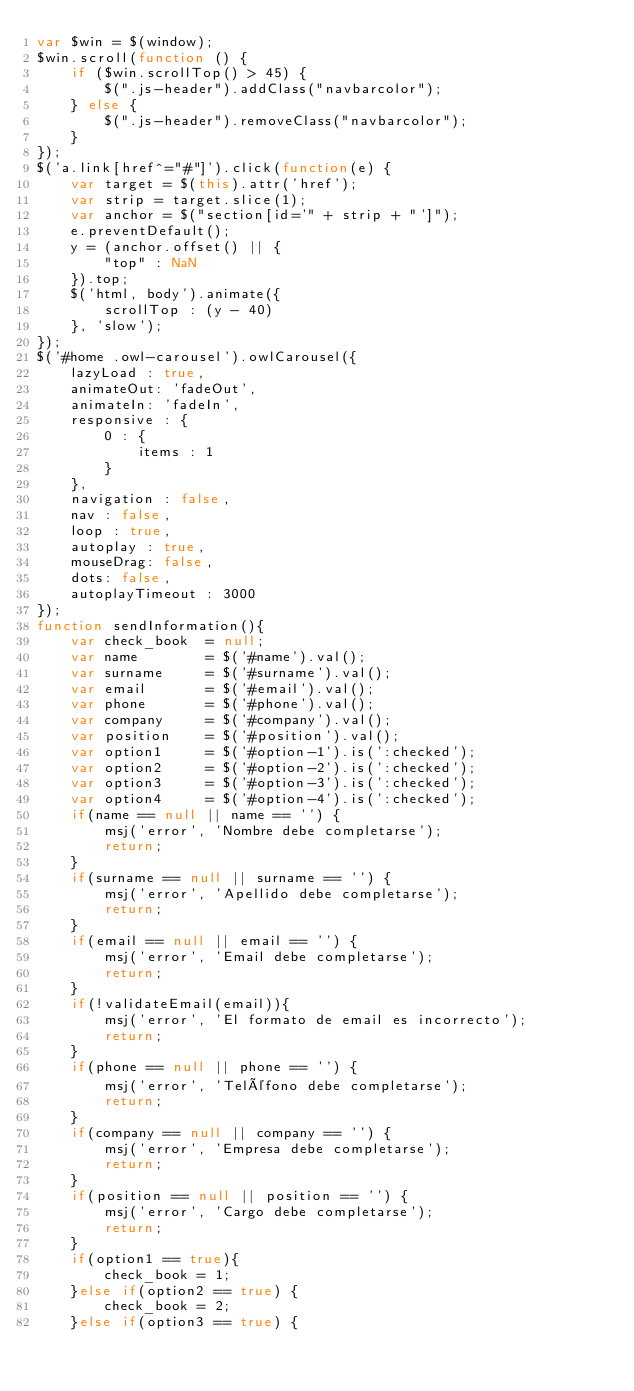<code> <loc_0><loc_0><loc_500><loc_500><_JavaScript_>var $win = $(window);
$win.scroll(function () {
	if ($win.scrollTop() > 45) {
		$(".js-header").addClass("navbarcolor");
	} else {
		$(".js-header").removeClass("navbarcolor");
	}
});
$('a.link[href^="#"]').click(function(e) {
 	var target = $(this).attr('href');
 	var strip = target.slice(1);
 	var anchor = $("section[id='" + strip + "']");
 	e.preventDefault();
 	y = (anchor.offset() || {
 		"top" : NaN
 	}).top;
 	$('html, body').animate({
 		scrollTop : (y - 40)
 	}, 'slow');
});
$('#home .owl-carousel').owlCarousel({
	lazyLoad : true,
	animateOut: 'fadeOut',
	animateIn: 'fadeIn',
	responsive : {
		0 : {
			items : 1
		}
	},
	navigation : false,
	nav : false,
	loop : true,
	autoplay : true,
	mouseDrag: false,
	dots: false,
	autoplayTimeout : 3000
});
function sendInformation(){
	var check_book  = null;
	var name 		= $('#name').val();
	var surname 	= $('#surname').val();
	var email 		= $('#email').val();
	var phone 		= $('#phone').val();
	var company 	= $('#company').val();
	var position 	= $('#position').val();
	var option1     = $('#option-1').is(':checked');
	var option2		= $('#option-2').is(':checked');
	var option3 	= $('#option-3').is(':checked');
	var option4		= $('#option-4').is(':checked');
	if(name == null || name == '') {
		msj('error', 'Nombre debe completarse');
		return;
	}
	if(surname == null || surname == '') {
		msj('error', 'Apellido debe completarse');
		return;
	}
	if(email == null || email == '') {
		msj('error', 'Email debe completarse');
		return;
	}
	if(!validateEmail(email)){
		msj('error', 'El formato de email es incorrecto');
		return;
	}
	if(phone == null || phone == '') {
		msj('error', 'Teléfono debe completarse');
		return;
	}
	if(company == null || company == '') {
		msj('error', 'Empresa debe completarse');
		return;
	}
	if(position == null || position == '') {
		msj('error', 'Cargo debe completarse');
		return;
	}
	if(option1 == true){
		check_book = 1;
	}else if(option2 == true) {
		check_book = 2;
	}else if(option3 == true) {</code> 